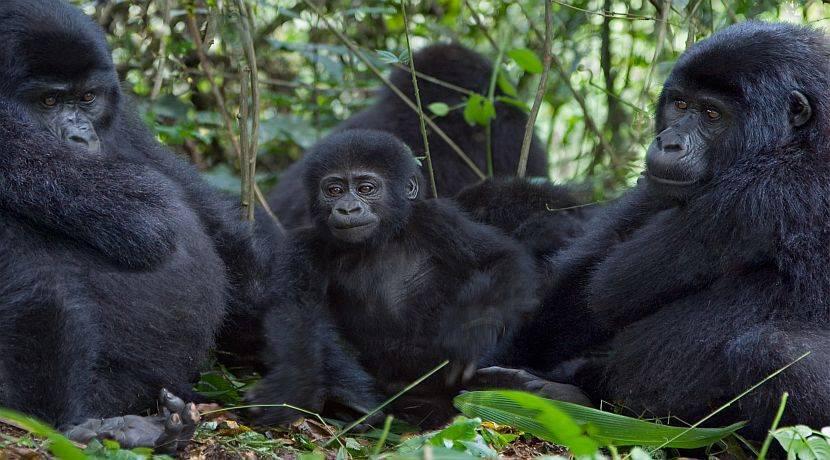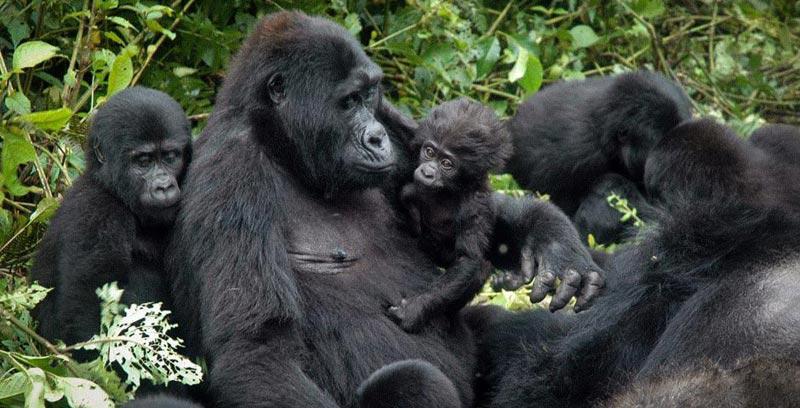The first image is the image on the left, the second image is the image on the right. For the images shown, is this caption "There is visible sky in one of the images." true? Answer yes or no. No. 